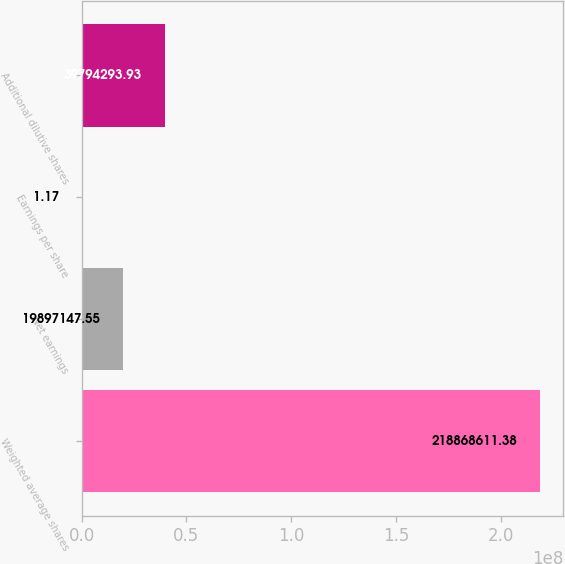Convert chart to OTSL. <chart><loc_0><loc_0><loc_500><loc_500><bar_chart><fcel>Weighted average shares<fcel>Net earnings<fcel>Earnings per share<fcel>Additional dilutive shares<nl><fcel>2.18869e+08<fcel>1.98971e+07<fcel>1.17<fcel>3.97943e+07<nl></chart> 